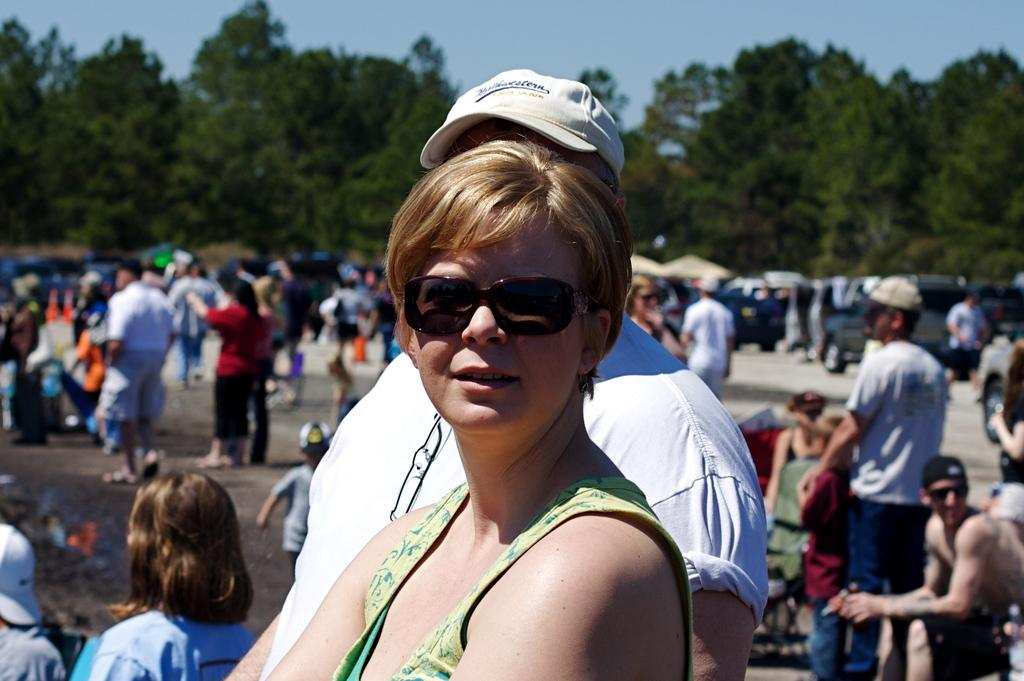Who is the main subject in the image? There is a woman in the image. What is the woman doing in the image? The woman is posing for a camera. What accessory is the woman wearing in the image? The woman is wearing goggles. What can be seen in the background of the image? There is a group of people, vehicles, trees, and the sky visible in the background of the image. What type of tin can be seen in the woman's hand in the image? There is no tin present in the woman's hand or in the image. What game are the people playing in the background of the image? There is no game or play activity depicted in the image; it only shows a woman posing for a camera and the background elements. 